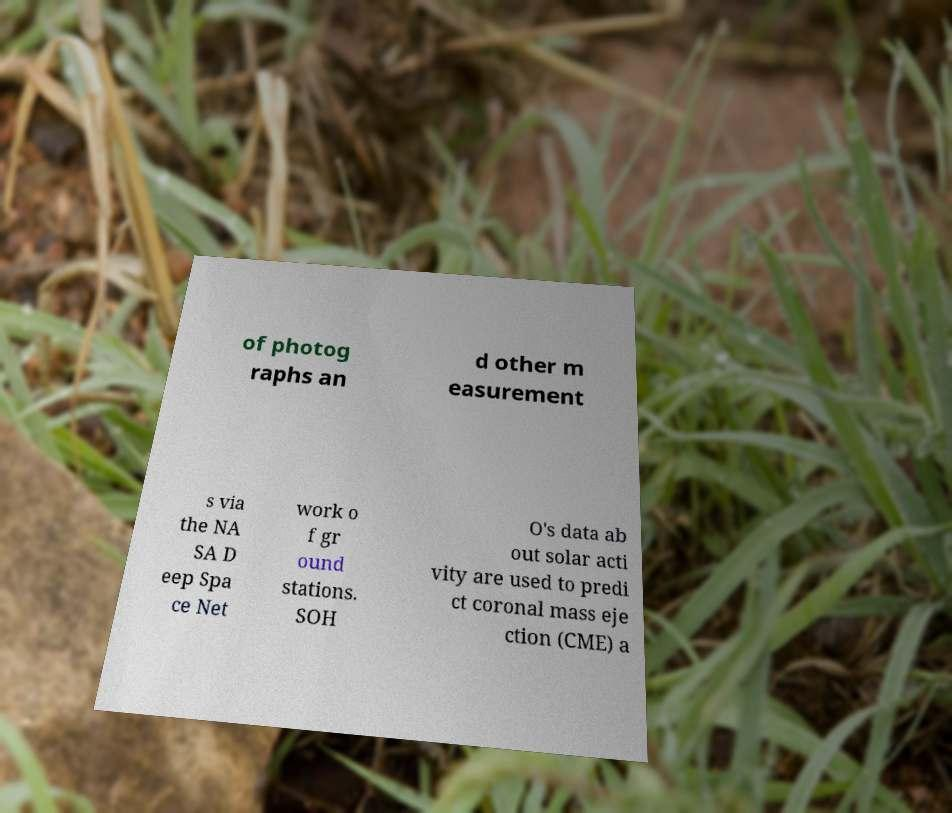Can you accurately transcribe the text from the provided image for me? of photog raphs an d other m easurement s via the NA SA D eep Spa ce Net work o f gr ound stations. SOH O's data ab out solar acti vity are used to predi ct coronal mass eje ction (CME) a 